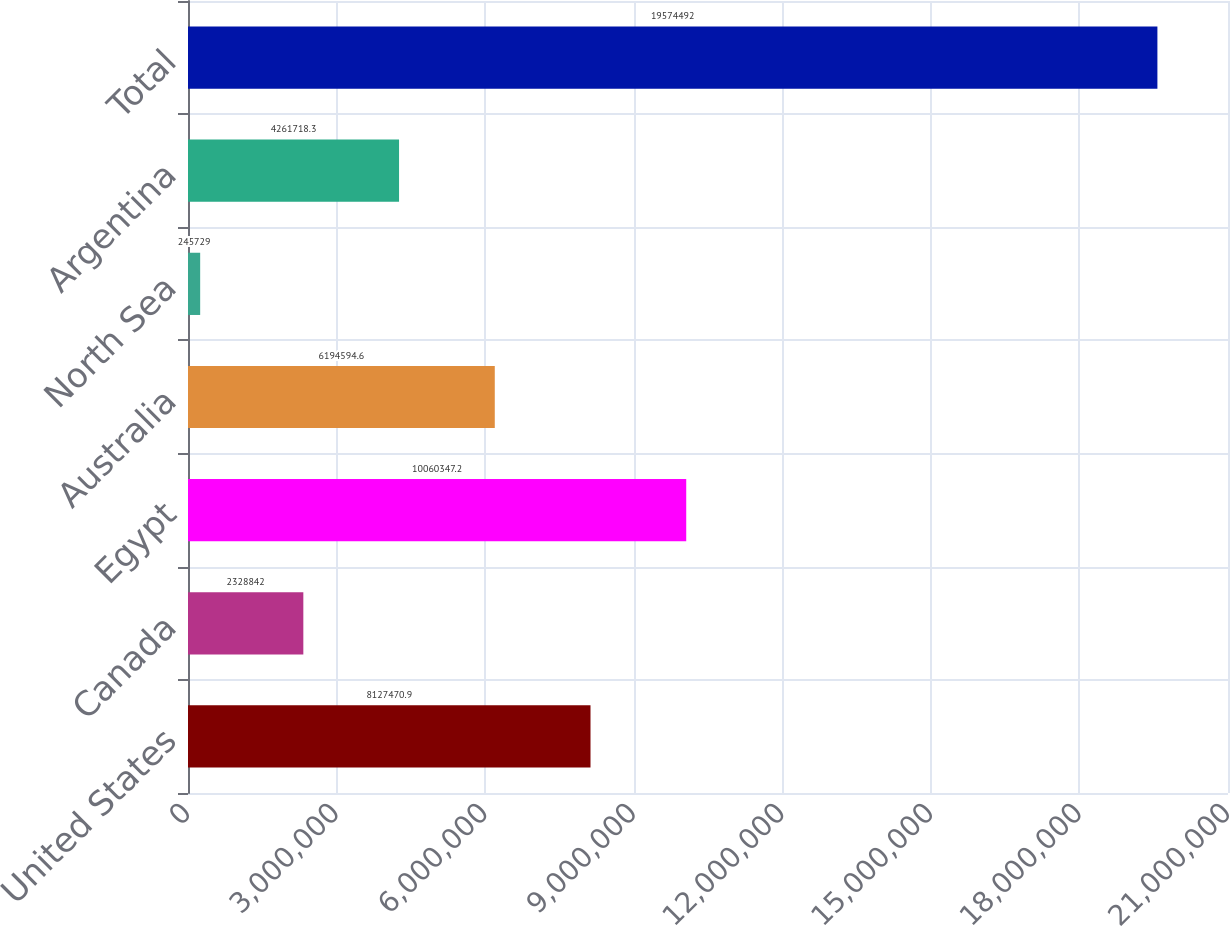Convert chart. <chart><loc_0><loc_0><loc_500><loc_500><bar_chart><fcel>United States<fcel>Canada<fcel>Egypt<fcel>Australia<fcel>North Sea<fcel>Argentina<fcel>Total<nl><fcel>8.12747e+06<fcel>2.32884e+06<fcel>1.00603e+07<fcel>6.19459e+06<fcel>245729<fcel>4.26172e+06<fcel>1.95745e+07<nl></chart> 